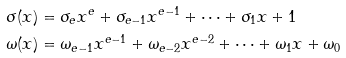<formula> <loc_0><loc_0><loc_500><loc_500>\sigma ( x ) & = \sigma _ { e } x ^ { e } + \sigma _ { e - 1 } x ^ { e - 1 } + \cdots + \sigma _ { 1 } x + 1 \\ \omega ( x ) & = \omega _ { e - 1 } x ^ { e - 1 } + \omega _ { e - 2 } x ^ { e - 2 } + \cdots + \omega _ { 1 } x + \omega _ { 0 }</formula> 